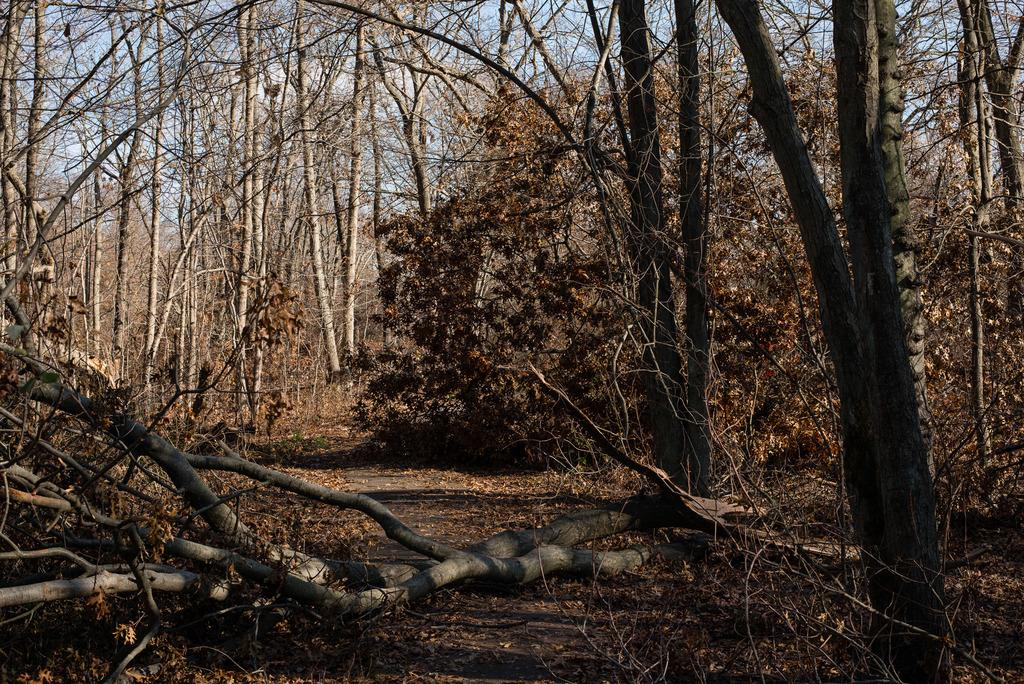What type of vegetation is present in the image? There are many trees in the image. What color is the sky in the image? The sky is blue in the image. What is present on the ground in the image? There are many dry leaves on the ground in the image. Can you see the brain of a person in the image? There is no brain visible in the image; it features trees, a blue sky, and dry leaves on the ground. What type of pin is present in the image? There is no pin present in the image. 